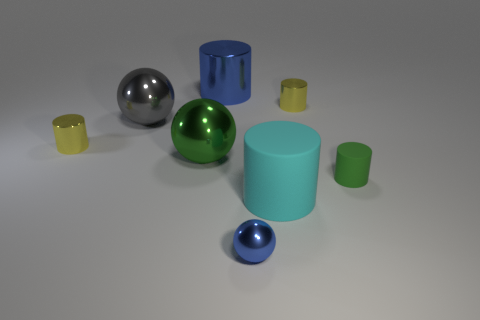Subtract all big green shiny spheres. How many spheres are left? 2 Subtract 4 cylinders. How many cylinders are left? 1 Subtract all cylinders. How many objects are left? 3 Subtract all blue spheres. How many spheres are left? 2 Subtract all green rubber objects. Subtract all blue cylinders. How many objects are left? 6 Add 1 small green rubber things. How many small green rubber things are left? 2 Add 3 big blue metallic objects. How many big blue metallic objects exist? 4 Add 1 metallic balls. How many objects exist? 9 Subtract 0 brown blocks. How many objects are left? 8 Subtract all brown balls. Subtract all brown cylinders. How many balls are left? 3 